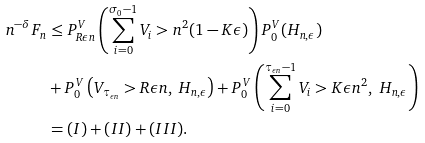Convert formula to latex. <formula><loc_0><loc_0><loc_500><loc_500>n ^ { - \delta } F _ { n } & \leq P _ { R \epsilon n } ^ { V } \left ( \sum _ { i = 0 } ^ { \sigma _ { 0 } - 1 } V _ { i } > n ^ { 2 } ( 1 - K \epsilon ) \right ) P _ { 0 } ^ { V } ( H _ { n , \epsilon } ) \\ & + P _ { 0 } ^ { V } \left ( V _ { \tau _ { \epsilon n } } > R \epsilon n , \ H _ { n , \epsilon } \right ) + P _ { 0 } ^ { V } \left ( \sum _ { i = 0 } ^ { \tau _ { \epsilon n } - 1 } V _ { i } > K \epsilon n ^ { 2 } , \ H _ { n , \epsilon } \right ) \\ & = ( I ) + ( I I ) + ( I I I ) .</formula> 